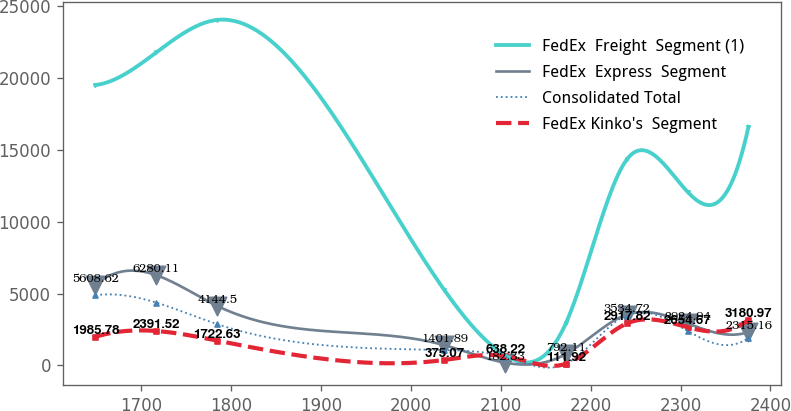<chart> <loc_0><loc_0><loc_500><loc_500><line_chart><ecel><fcel>FedEx  Freight  Segment (1)<fcel>FedEx  Express  Segment<fcel>Consolidated Total<fcel>FedEx Kinko's  Segment<nl><fcel>1649.23<fcel>19518.2<fcel>5608.62<fcel>4879.71<fcel>1985.78<nl><fcel>1716.85<fcel>21786.1<fcel>6280.11<fcel>4369.32<fcel>2391.52<nl><fcel>1784.47<fcel>24054.1<fcel>4144.5<fcel>2874.67<fcel>1722.63<nl><fcel>2037.47<fcel>5229.8<fcel>1401.89<fcel>1065.3<fcel>375.07<nl><fcel>2105.09<fcel>693.92<fcel>182.33<fcel>588.5<fcel>638.22<nl><fcel>2172.71<fcel>2961.86<fcel>792.11<fcel>111.7<fcel>111.92<nl><fcel>2240.33<fcel>14340.8<fcel>3534.72<fcel>3512.05<fcel>2917.82<nl><fcel>2307.95<fcel>12072.9<fcel>2924.94<fcel>2397.87<fcel>2654.67<nl><fcel>2375.57<fcel>16608.8<fcel>2315.16<fcel>1921.07<fcel>3180.97<nl></chart> 